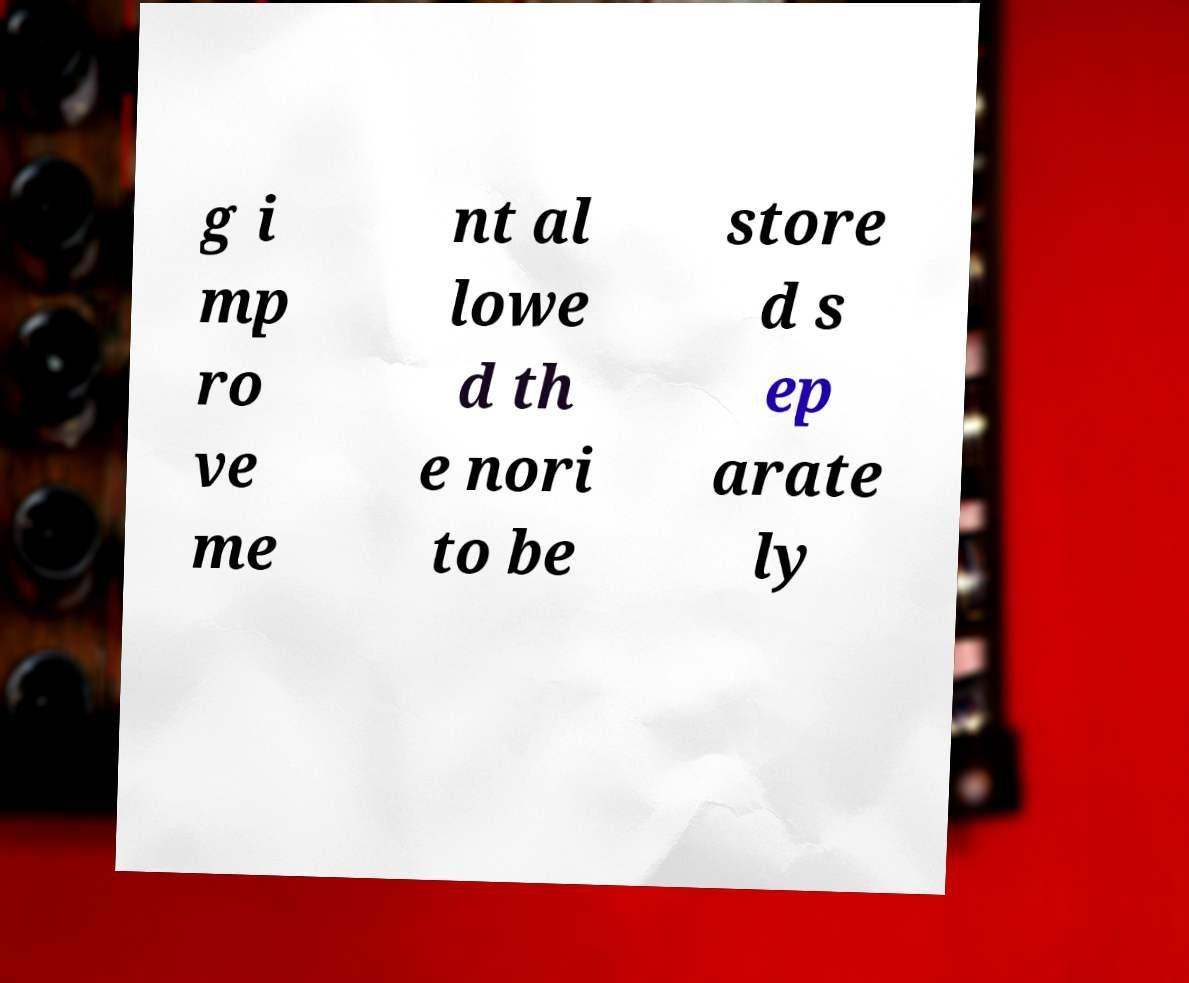For documentation purposes, I need the text within this image transcribed. Could you provide that? g i mp ro ve me nt al lowe d th e nori to be store d s ep arate ly 